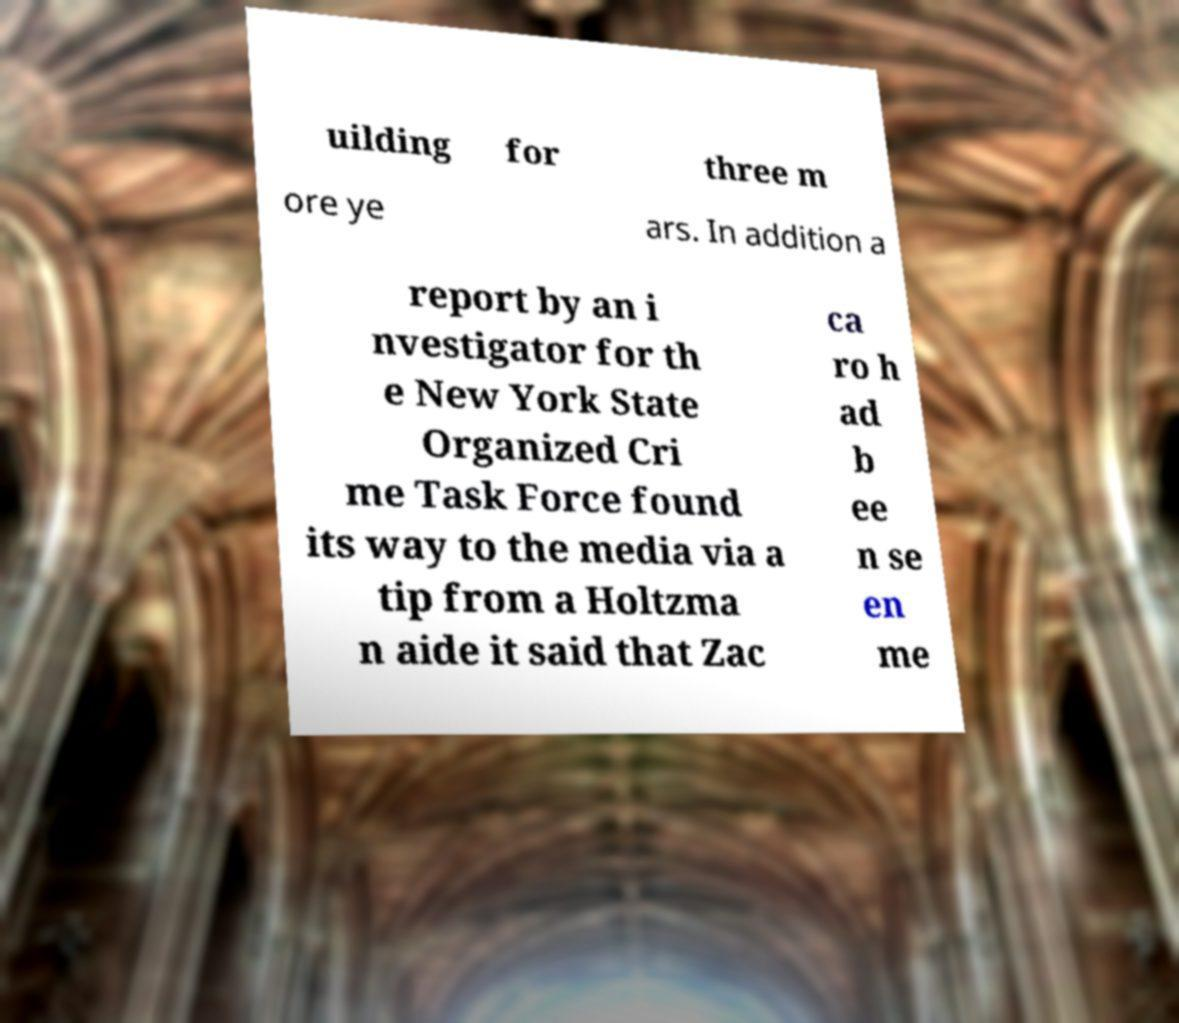What messages or text are displayed in this image? I need them in a readable, typed format. uilding for three m ore ye ars. In addition a report by an i nvestigator for th e New York State Organized Cri me Task Force found its way to the media via a tip from a Holtzma n aide it said that Zac ca ro h ad b ee n se en me 